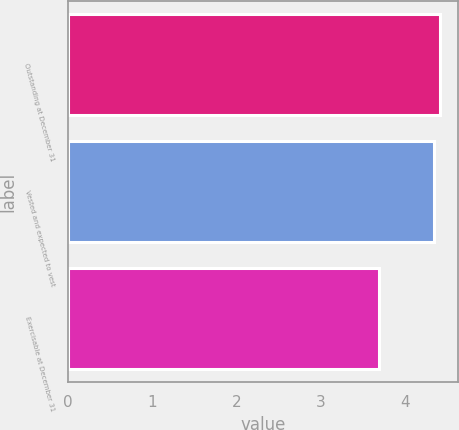<chart> <loc_0><loc_0><loc_500><loc_500><bar_chart><fcel>Outstanding at December 31<fcel>Vested and expected to vest<fcel>Exercisable at December 31<nl><fcel>4.42<fcel>4.35<fcel>3.7<nl></chart> 